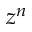<formula> <loc_0><loc_0><loc_500><loc_500>z ^ { n }</formula> 